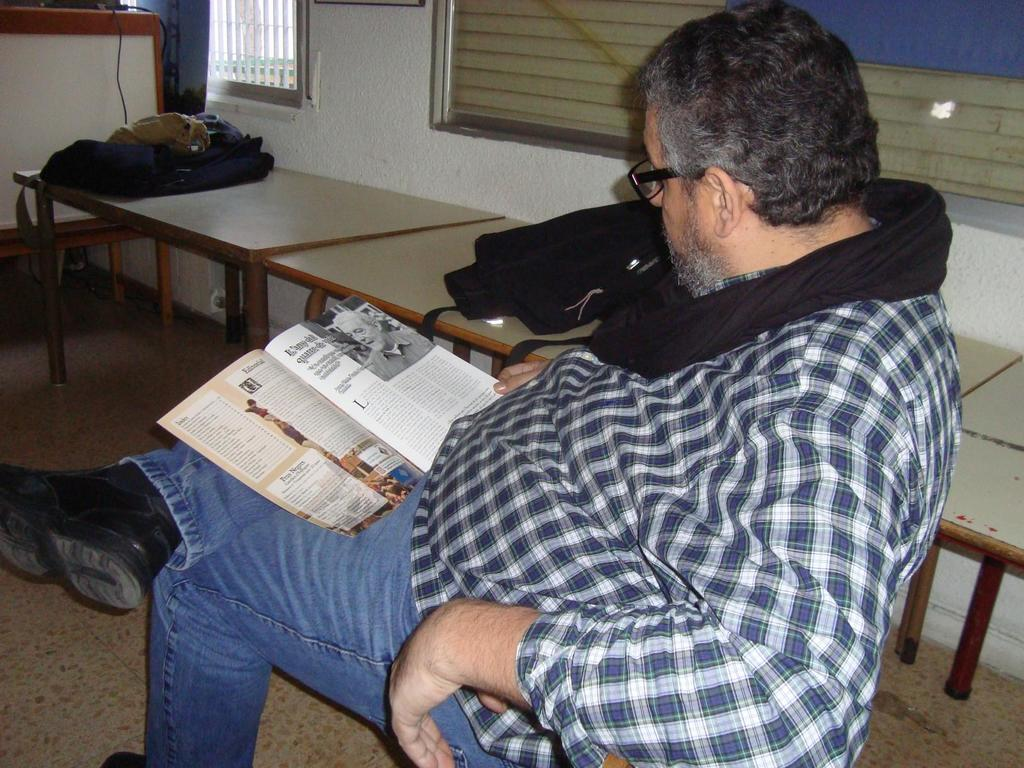What is the man in the image doing? The man is sitting and reading a book in the image. What object can be seen near the man? There is a table in the image. What item is the man holding? The man is holding a book. What is visible in the background of the image? There is a window and a wall in the background of the image. What might the man be using to carry items? There is a bag in the image, which could be used for carrying items. How many beasts can be seen smashing through the window in the image? There are no beasts present in the image, nor is there any indication of smashing through the window. 